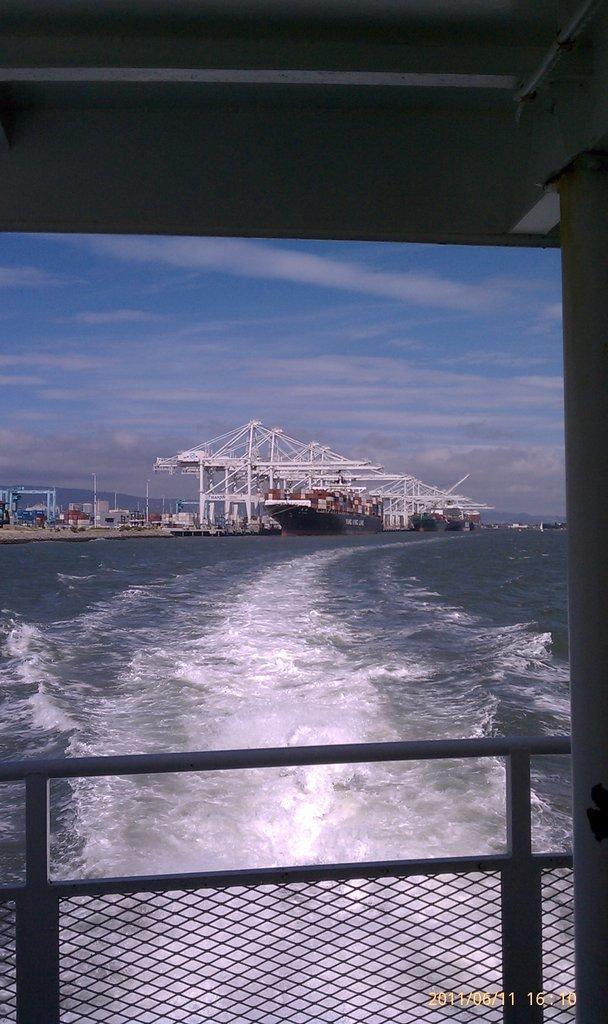Describe this image in one or two sentences. In this image I can see the railing, the water and a ship which is black in color on the surface of the water. I can see few cranes which are white in color, few containers and the sky in the background. 